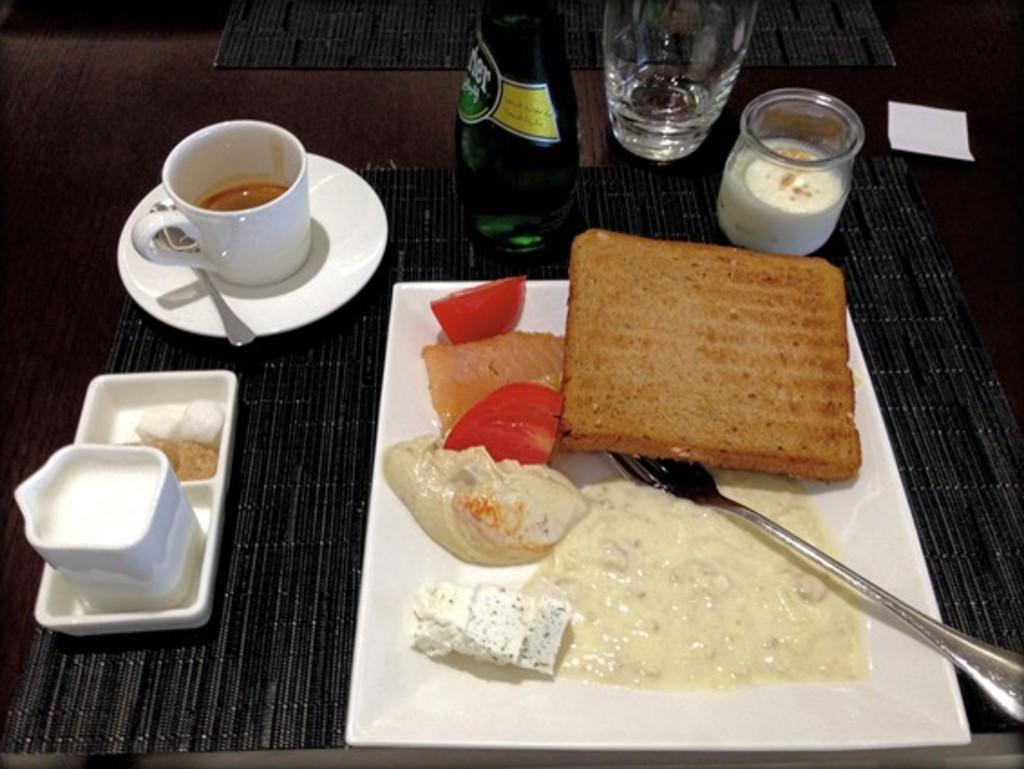What type of bread is in the image? There is a brown bread in the image. What is on the white plate in the image? There is cream on a white plate in the image. Where is the plate with cream placed? The plate is placed on a dining table. What other items can be seen on the dining table? There is a white teacup, a water glass, and a mayonnaise cup in the image. What is the name of the person who made the brown bread in the image? There is no information about the person who made the brown bread in the image, so we cannot determine their name. 